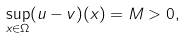Convert formula to latex. <formula><loc_0><loc_0><loc_500><loc_500>\sup _ { x \in \Omega } ( u - v ) ( x ) = M > 0 ,</formula> 